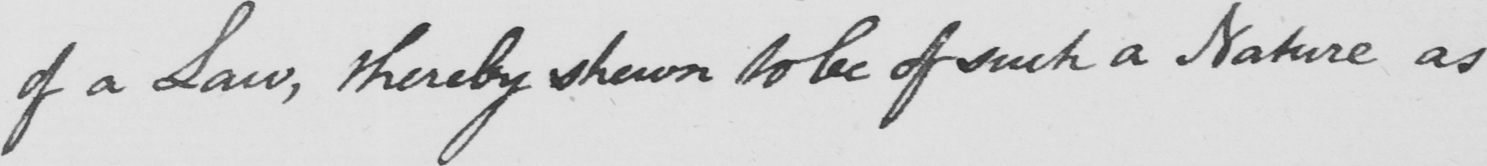What is written in this line of handwriting? of a Law , thereby shewn to be of such a Nature as 